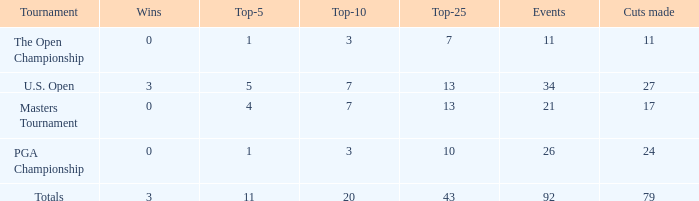Name the average cuts for top-25 more than 13 and top-5 less than 11 None. 